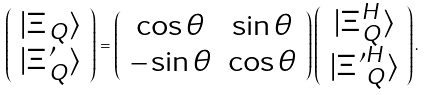Convert formula to latex. <formula><loc_0><loc_0><loc_500><loc_500>\left ( \begin{array} { c } | { \sl \Xi } _ { Q } \rangle \\ | { \sl \Xi } ^ { \prime } _ { Q } \rangle \end{array} \right ) = \left ( \begin{array} { c c } \cos \theta & \sin \theta \\ - \sin \theta & \cos \theta \end{array} \right ) \left ( \begin{array} { c } | { \sl \Xi } _ { Q } ^ { H } \rangle \\ | { { \sl \Xi } ^ { \prime } } ^ { H } _ { Q } \rangle \end{array} \right ) .</formula> 